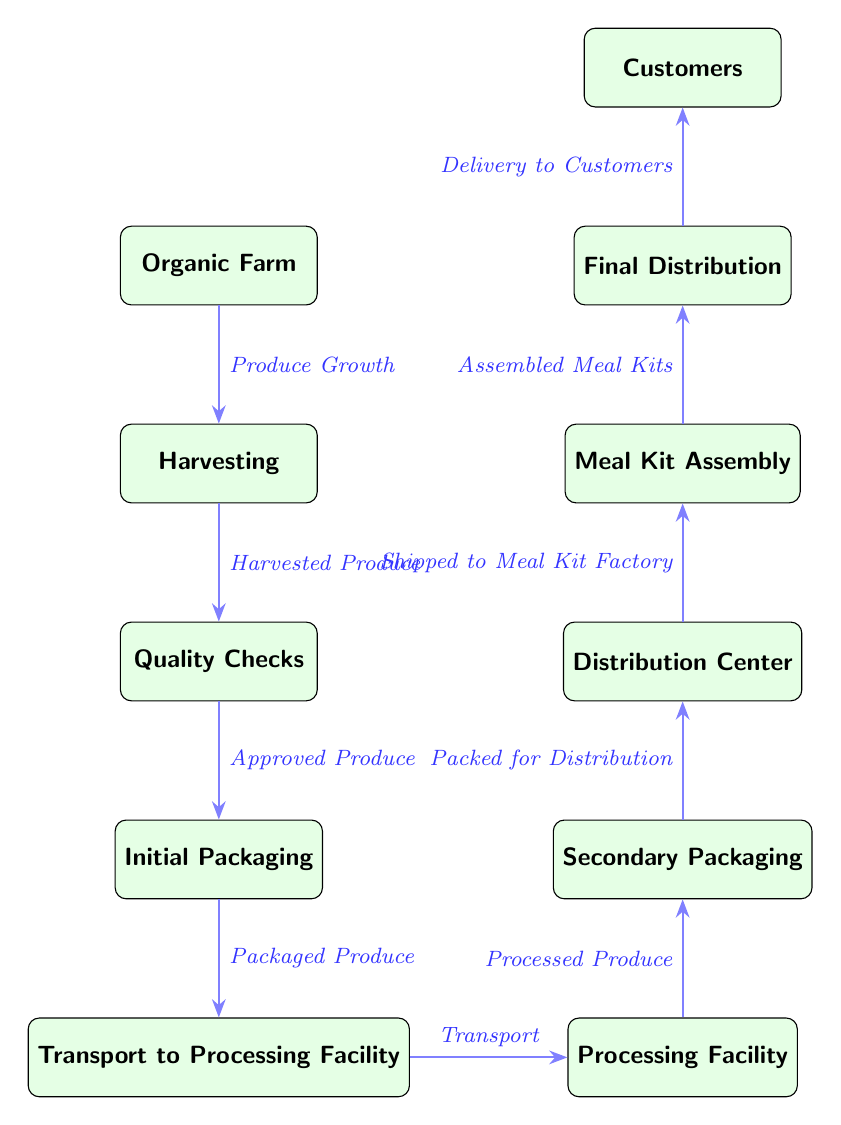What is the first node in the supply chain process? The diagram starts with the node labeled "Organic Farm," which is the first step in the supply chain process.
Answer: Organic Farm How many main stages are there in the supply chain process? Counting the nodes in the diagram, there are a total of 10 main stages from "Organic Farm" to "Customers."
Answer: 10 What is the output of the harvesting stage? The harvesting stage outputs "Harvested Produce," as indicated by the arrow leading to the next node.
Answer: Harvested Produce Which stage directly follows the quality checks? The stage that comes directly after "Quality Checks" is "Initial Packaging," as shown in the flow of the diagram.
Answer: Initial Packaging What type of produce moves from processing to secondary packaging? The type of produce being processed and then moved to the next stage is referred to as "Processed Produce."
Answer: Processed Produce What is the connection between the distribution center and meal kit assembly? The connection indicates that the "Distribution Center" sends "Shipped to Meal Kit Factory," leading to the "Meal Kit Assembly."
Answer: Shipped to Meal Kit Factory Which stage is preceded by transport? The stage that comes right after "Transport" is "Processing Facility," indicating the flow of the supply chain process.
Answer: Processing Facility How many arrows are there in the diagram? By counting the arrows representing the connections between stages, there are a total of 9 arrows in the diagram.
Answer: 9 What happens after the meal kit assembly? After "Meal Kit Assembly," the next stage is "Final Distribution," which follows in the sequence.
Answer: Final Distribution What is the final destination of the supply chain process? The final destination, represented as the last node in the diagram, is labeled "Customers." This shows where the meal kits are delivered.
Answer: Customers 